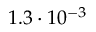Convert formula to latex. <formula><loc_0><loc_0><loc_500><loc_500>1 . 3 \cdot 1 0 ^ { - 3 }</formula> 